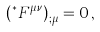Convert formula to latex. <formula><loc_0><loc_0><loc_500><loc_500>\left ( ^ { \ast } F ^ { \mu \nu } \right ) _ { ; \mu } = 0 \, ,</formula> 